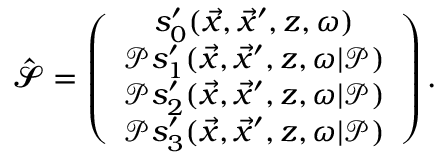Convert formula to latex. <formula><loc_0><loc_0><loc_500><loc_500>\begin{array} { r } { { \widehat { \mathbf c a l { S } } } = \left ( \begin{array} { c } { s _ { 0 } ^ { \prime } ( \vec { x } , \vec { x } ^ { \prime } , z , \omega ) } \\ { \mathcal { P } s _ { 1 } ^ { \prime } ( \vec { x } , \vec { x } ^ { \prime } , z , \omega | \mathcal { P } ) } \\ { \mathcal { P } s _ { 2 } ^ { \prime } ( \vec { x } , \vec { x } ^ { \prime } , z , \omega | \mathcal { P } ) } \\ { \mathcal { P } s _ { 3 } ^ { \prime } ( \vec { x } , \vec { x } ^ { \prime } , z , \omega | \mathcal { P } ) } \end{array} \right ) . } \end{array}</formula> 